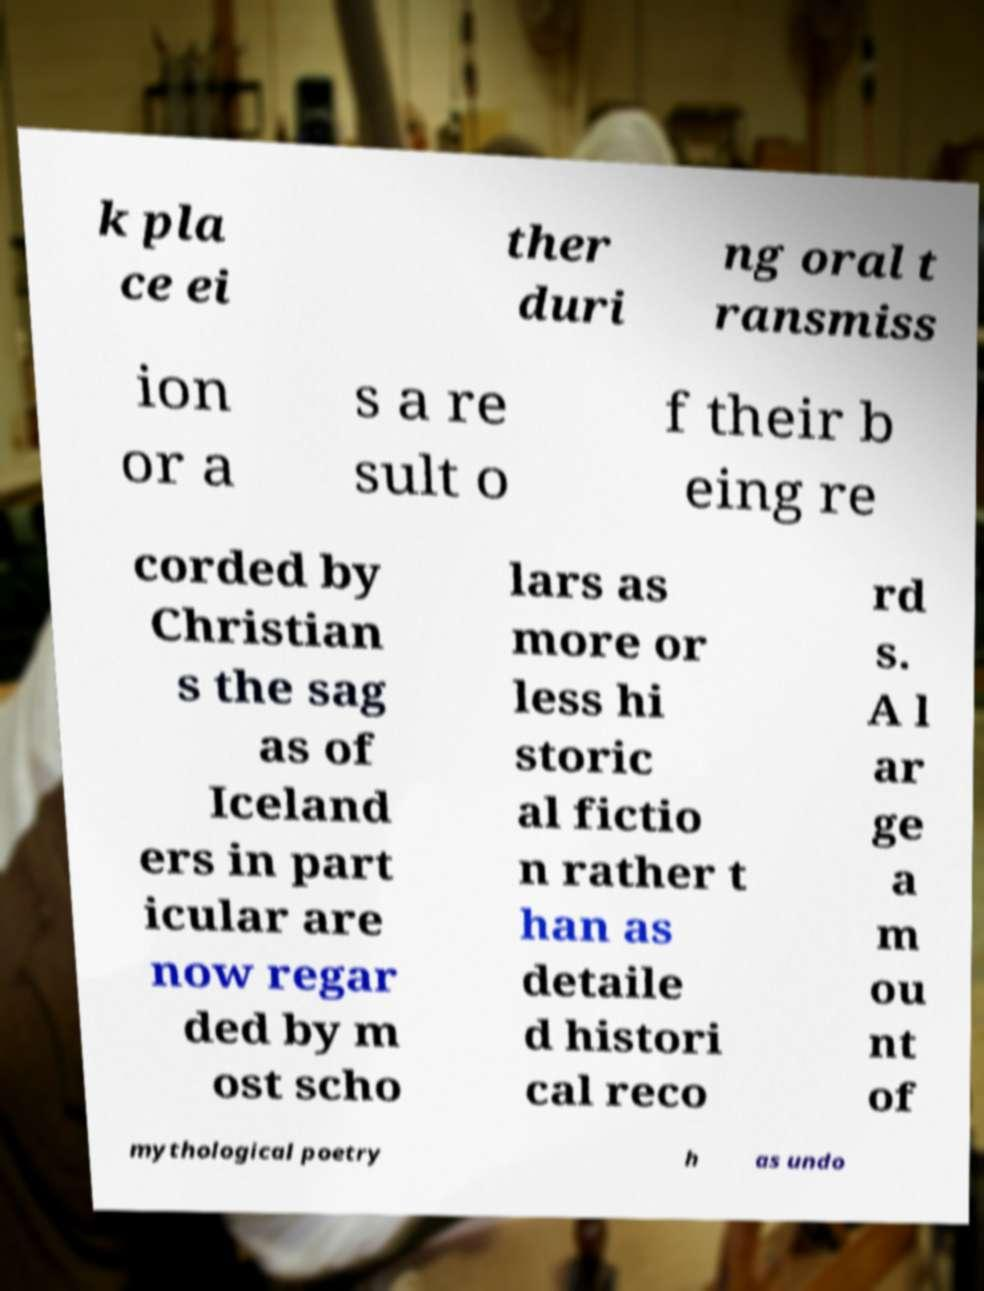There's text embedded in this image that I need extracted. Can you transcribe it verbatim? k pla ce ei ther duri ng oral t ransmiss ion or a s a re sult o f their b eing re corded by Christian s the sag as of Iceland ers in part icular are now regar ded by m ost scho lars as more or less hi storic al fictio n rather t han as detaile d histori cal reco rd s. A l ar ge a m ou nt of mythological poetry h as undo 